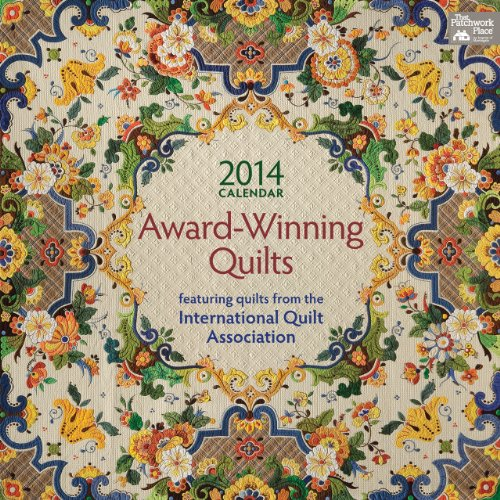Is this a romantic book? No, this book is not romantic. It is primarily a calendar featuring a compilation of quilts, focusing on artistry in quilt-making rather than romantic content. 